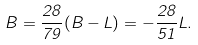<formula> <loc_0><loc_0><loc_500><loc_500>B = \frac { 2 8 } { 7 9 } ( B - L ) = - \frac { 2 8 } { 5 1 } L .</formula> 